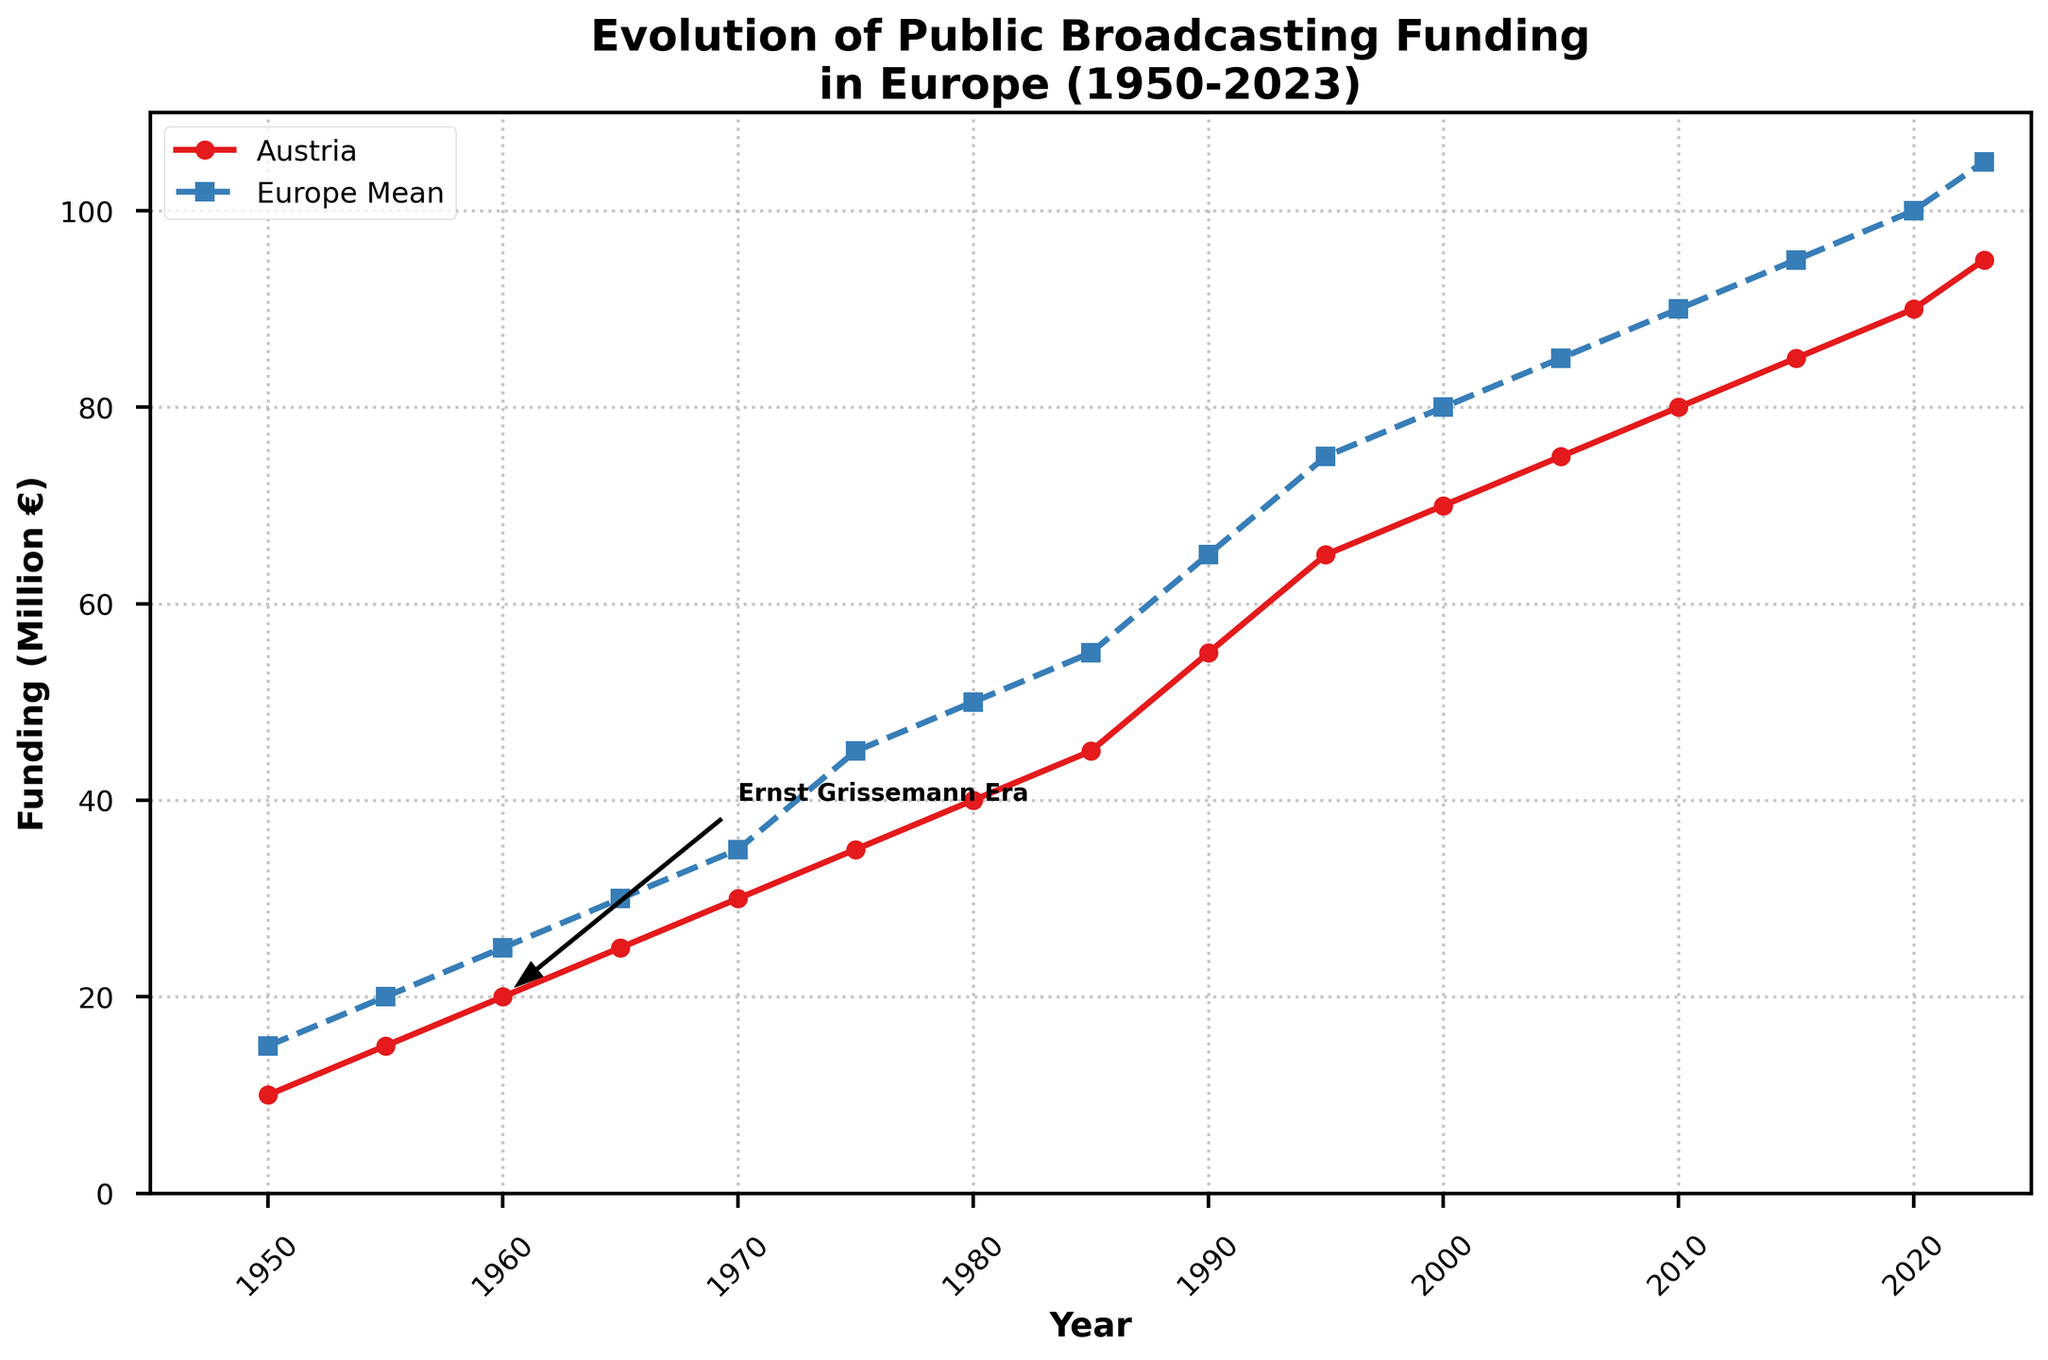What is the title of the figure? The title of the figure is located at the top and provides an overview of the visual representation. It reads "Evolution of Public Broadcasting Funding in Europe (1950-2023)."
Answer: Evolution of Public Broadcasting Funding in Europe (1950-2023) What are the labels for the x-axis and y-axis? The labels for the x-axis and y-axis, which describe what each axis represents, are "Year" and "Funding (Million €)" respectively.
Answer: Year; Funding (Million €) What is the color of the line representing Austria's funding? Austria's funding line can be identified by its unique color. It is marked in red.
Answer: Red In which year is the funding for Austria equal to 75 million €? To find the year when Austria's funding reaches 75 million €, look for the data point on Austria's line plot corresponding to 75 million €. This occurs in 2005.
Answer: 2005 What is the difference in funding between Austria and the European mean in 1980? For 1980, Austria's funding is 40 million €, and the European mean is 50 million €. Subtract Austria's funding from the European mean: 50 - 40 = 10 million €.
Answer: 10 million € Which year marks the beginning of the annotated "Ernst Grissemann Era"? The annotation "Ernst Grissemann Era" has an arrow pointing to a specific year, which is 1960.
Answer: 1960 How does Austria's funding compare to the European mean in 2020? To compare these, look at the funding values in 2020 for Austria and the European mean. Austria has 90 million € and the European mean is 100 million €, so Austria's funding is 10 million € less.
Answer: 10 million € less During which decade did Austria's funding surpass the European mean for the first time? By observing both lines, one can see that Austria's funding surpassed the European mean around 1990. This is the first instance.
Answer: 1990s What is the average funding for Austria from 1950 to 2023? Sum the Austria funding values from 1950 to 2023 and divide by the number of data points (16): (10+15+20+25+30+35+40+45+55+65+70+75+80+85+90+95)/16 = 55 million €.
Answer: 55 million € Between 2000 and 2023, what is the total increase in Austria's funding? The funding for Austria in 2000 was 70 million €, and in 2023 it was 95 million €. Subtract the initial funding from the final funding: 95 - 70 = 25 million €.
Answer: 25 million € 